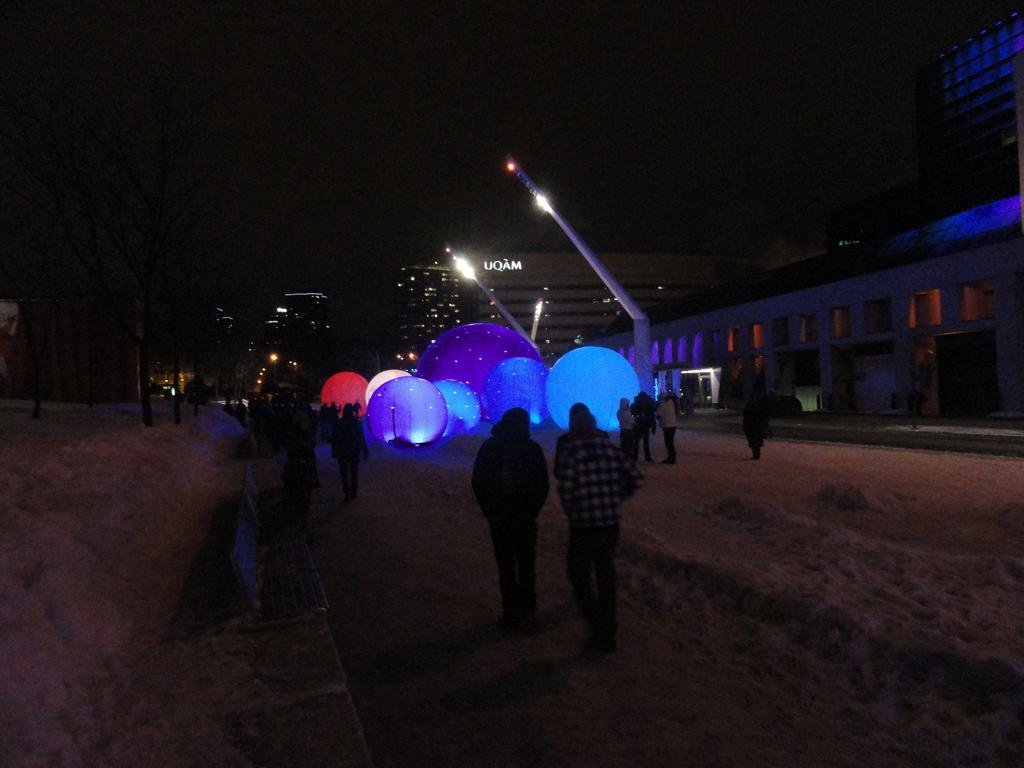Who or what can be seen in the image? There are people in the image. What decorative items are present in the image? There are colorful balloons in the image. What type of structures are visible in the image? There are buildings in the image. What are the poles used for in the image? The poles are likely used for supporting lights or other decorations in the image. What type of illumination is present in the image? There are lights in the image. What type of natural elements are visible in the image? There are trees in the image. How would you describe the overall lighting in the image? The background of the image is dark. In which direction are the people in the image traveling? There is no indication of the people's direction of travel in the image. What type of building is the focus of the journey in the image? There is no journey or building mentioned as the focus in the image. 